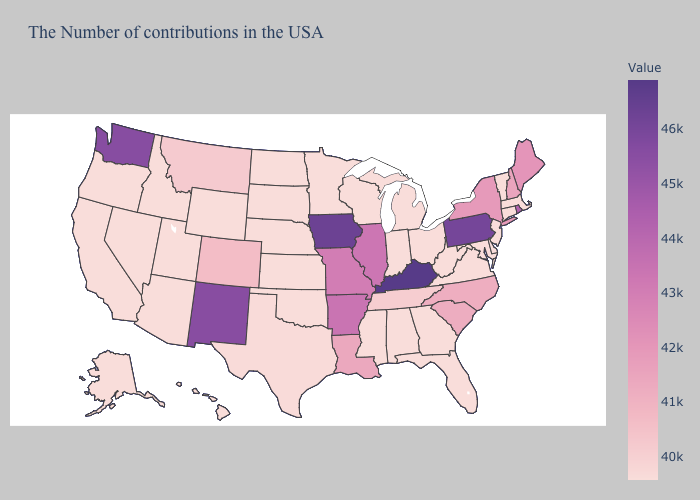Does the map have missing data?
Give a very brief answer. No. Does Kentucky have the highest value in the USA?
Write a very short answer. Yes. Which states have the lowest value in the USA?
Quick response, please. Massachusetts, Vermont, Connecticut, New Jersey, Delaware, Maryland, Virginia, West Virginia, Ohio, Florida, Georgia, Michigan, Indiana, Alabama, Wisconsin, Mississippi, Minnesota, Kansas, Nebraska, Oklahoma, South Dakota, North Dakota, Wyoming, Utah, Arizona, Idaho, Nevada, California, Oregon, Alaska, Hawaii. Among the states that border Nebraska , does Iowa have the highest value?
Concise answer only. Yes. Among the states that border Texas , does Oklahoma have the lowest value?
Give a very brief answer. Yes. Among the states that border Wyoming , which have the highest value?
Keep it brief. Colorado. Does Pennsylvania have the highest value in the Northeast?
Write a very short answer. Yes. 